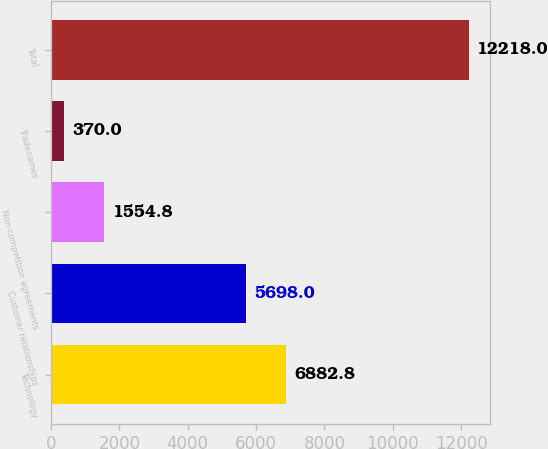Convert chart. <chart><loc_0><loc_0><loc_500><loc_500><bar_chart><fcel>Technology<fcel>Customer relationships<fcel>Non-competition agreements<fcel>Tradenames<fcel>Total<nl><fcel>6882.8<fcel>5698<fcel>1554.8<fcel>370<fcel>12218<nl></chart> 